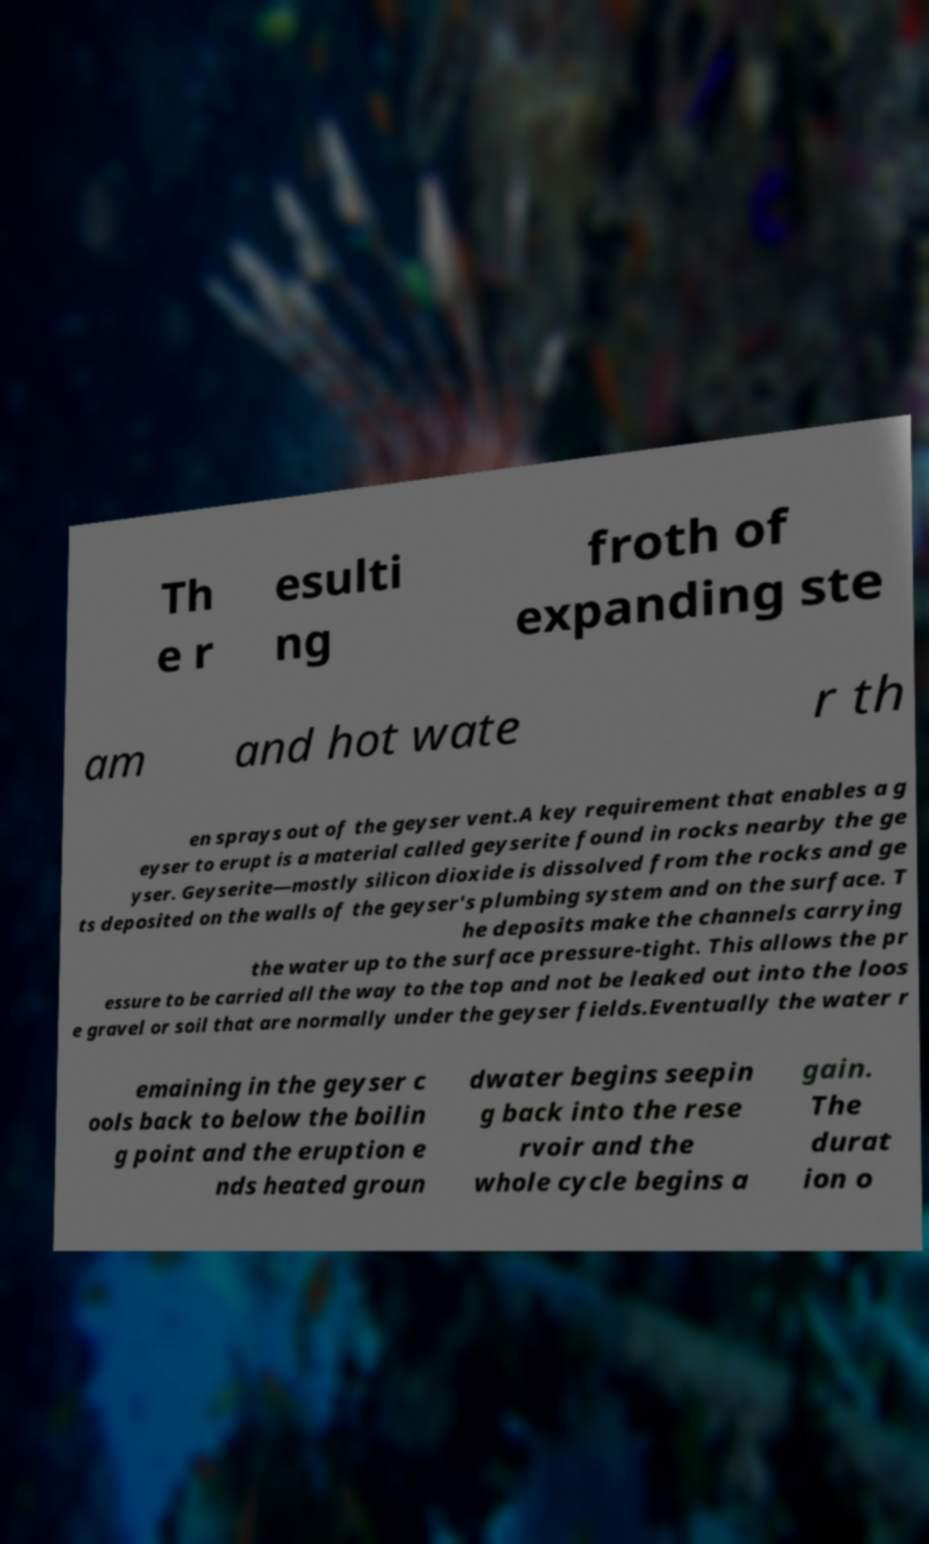Can you accurately transcribe the text from the provided image for me? Th e r esulti ng froth of expanding ste am and hot wate r th en sprays out of the geyser vent.A key requirement that enables a g eyser to erupt is a material called geyserite found in rocks nearby the ge yser. Geyserite—mostly silicon dioxide is dissolved from the rocks and ge ts deposited on the walls of the geyser's plumbing system and on the surface. T he deposits make the channels carrying the water up to the surface pressure-tight. This allows the pr essure to be carried all the way to the top and not be leaked out into the loos e gravel or soil that are normally under the geyser fields.Eventually the water r emaining in the geyser c ools back to below the boilin g point and the eruption e nds heated groun dwater begins seepin g back into the rese rvoir and the whole cycle begins a gain. The durat ion o 